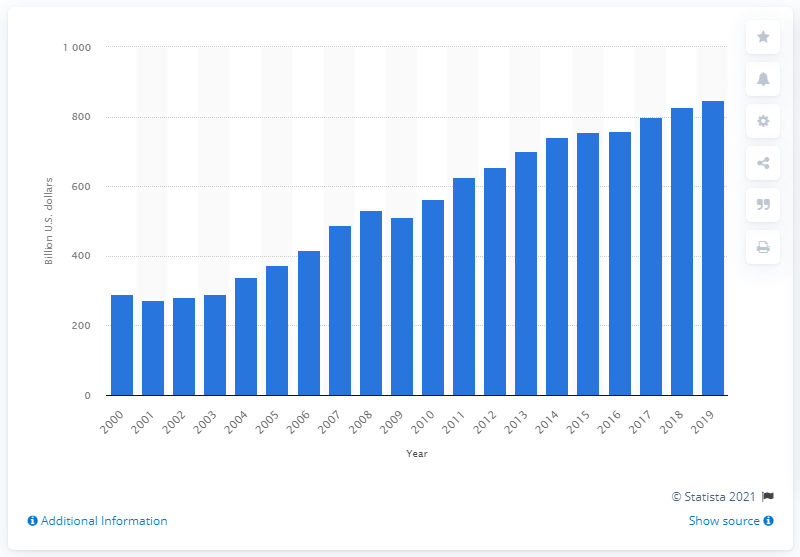Give some essential details in this illustration. In 2019, the value of international U.S. exports of services was $846.72 billion. 